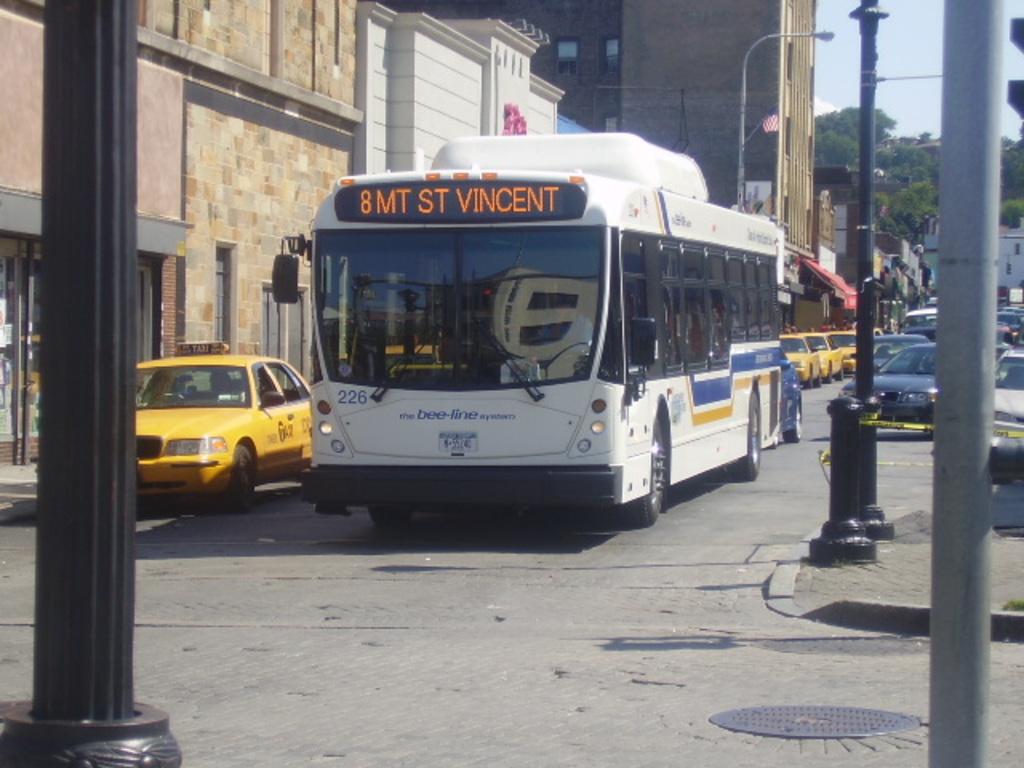Where is this bus going?
Provide a short and direct response. 8 mt st vincent. What stop is mt st vincent?
Ensure brevity in your answer.  8. 